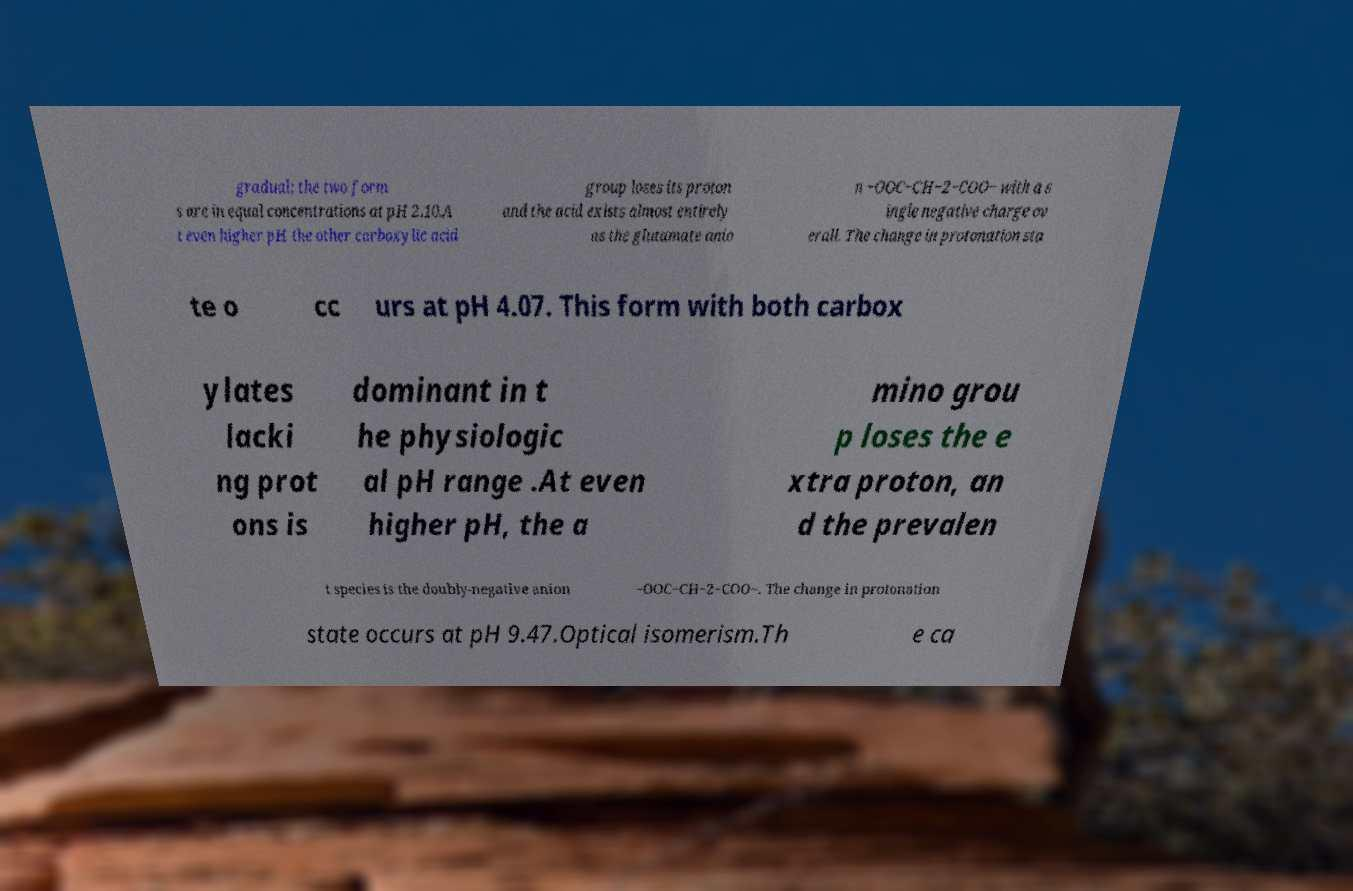Could you assist in decoding the text presented in this image and type it out clearly? gradual; the two form s are in equal concentrations at pH 2.10.A t even higher pH the other carboxylic acid group loses its proton and the acid exists almost entirely as the glutamate anio n −OOC−CH−2−COO− with a s ingle negative charge ov erall. The change in protonation sta te o cc urs at pH 4.07. This form with both carbox ylates lacki ng prot ons is dominant in t he physiologic al pH range .At even higher pH, the a mino grou p loses the e xtra proton, an d the prevalen t species is the doubly-negative anion −OOC−CH−2−COO−. The change in protonation state occurs at pH 9.47.Optical isomerism.Th e ca 